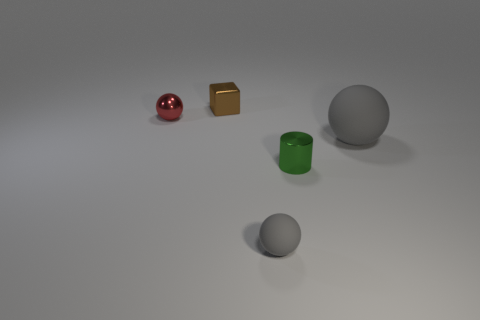Add 1 brown cubes. How many objects exist? 6 Subtract all spheres. How many objects are left? 2 Add 1 shiny blocks. How many shiny blocks are left? 2 Add 4 cylinders. How many cylinders exist? 5 Subtract 0 cyan blocks. How many objects are left? 5 Subtract all red metallic spheres. Subtract all small gray balls. How many objects are left? 3 